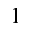Convert formula to latex. <formula><loc_0><loc_0><loc_500><loc_500>1</formula> 